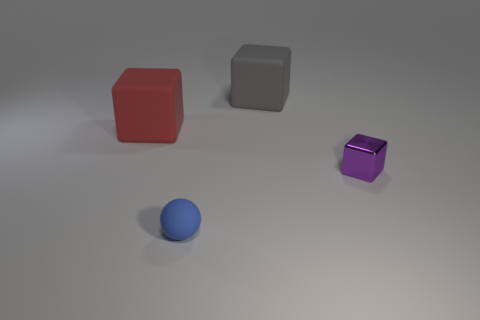Is there anything else that has the same material as the large red thing?
Ensure brevity in your answer.  Yes. What number of other things are there of the same size as the blue thing?
Make the answer very short. 1. Do the object on the left side of the blue matte object and the shiny thing have the same shape?
Keep it short and to the point. Yes. What shape is the big thing to the left of the big block that is behind the block on the left side of the gray matte thing?
Provide a short and direct response. Cube. What is the object that is both to the left of the big gray rubber block and on the right side of the red matte block made of?
Your answer should be compact. Rubber. Are there fewer gray shiny blocks than balls?
Make the answer very short. Yes. Do the red thing and the object that is in front of the tiny metallic thing have the same shape?
Offer a terse response. No. Does the matte cube to the left of the gray object have the same size as the purple metal thing?
Provide a succinct answer. No. What is the shape of the other object that is the same size as the red matte object?
Ensure brevity in your answer.  Cube. Is the shape of the big red matte thing the same as the small purple metallic thing?
Offer a terse response. Yes. 